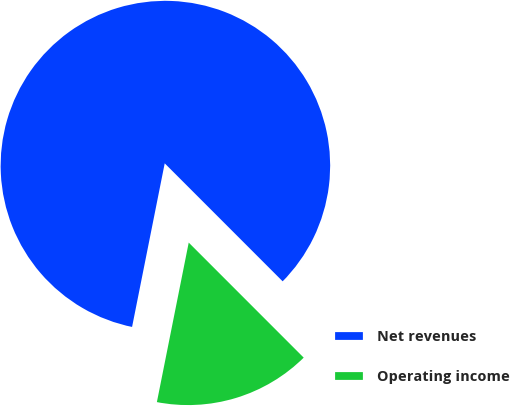<chart> <loc_0><loc_0><loc_500><loc_500><pie_chart><fcel>Net revenues<fcel>Operating income<nl><fcel>84.37%<fcel>15.63%<nl></chart> 